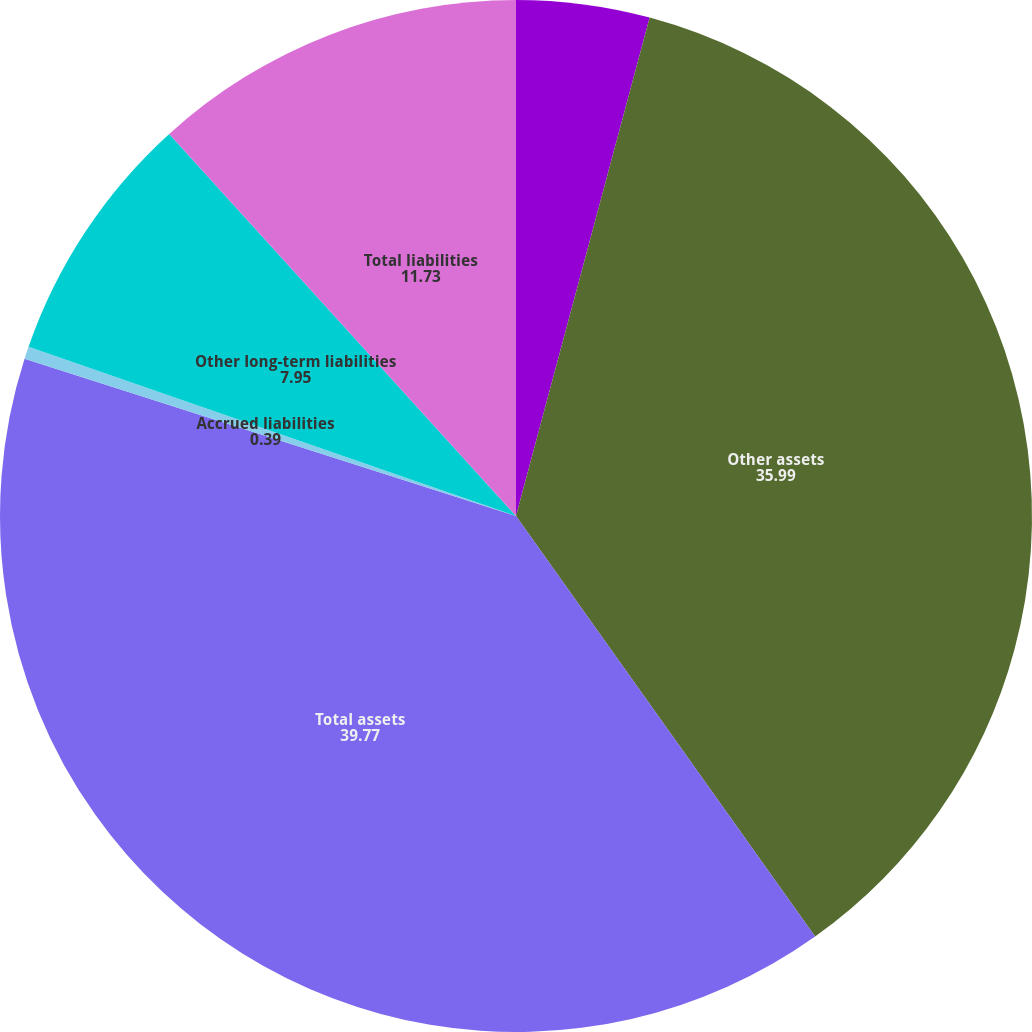<chart> <loc_0><loc_0><loc_500><loc_500><pie_chart><fcel>Prepaid expenses and other<fcel>Other assets<fcel>Total assets<fcel>Accrued liabilities<fcel>Other long-term liabilities<fcel>Total liabilities<nl><fcel>4.17%<fcel>35.99%<fcel>39.77%<fcel>0.39%<fcel>7.95%<fcel>11.73%<nl></chart> 